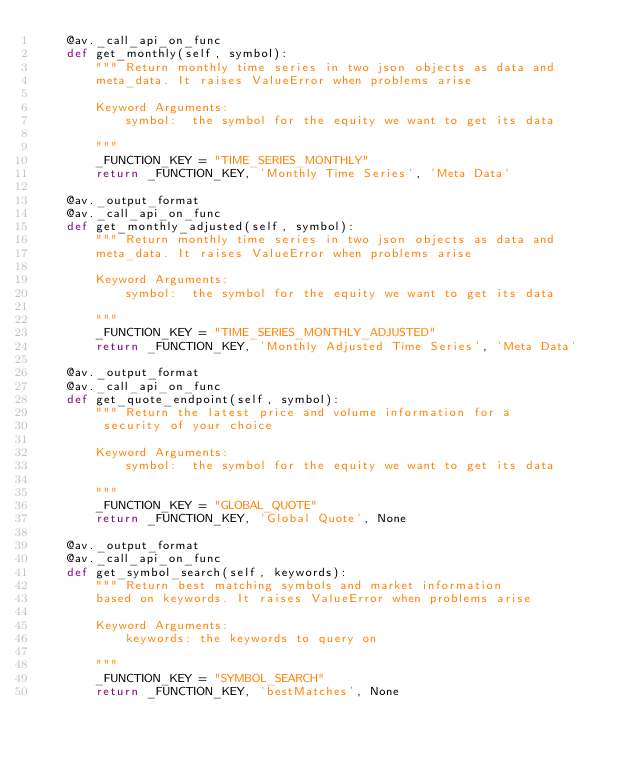Convert code to text. <code><loc_0><loc_0><loc_500><loc_500><_Python_>    @av._call_api_on_func
    def get_monthly(self, symbol):
        """ Return monthly time series in two json objects as data and
        meta_data. It raises ValueError when problems arise

        Keyword Arguments:
            symbol:  the symbol for the equity we want to get its data

        """
        _FUNCTION_KEY = "TIME_SERIES_MONTHLY"
        return _FUNCTION_KEY, 'Monthly Time Series', 'Meta Data'

    @av._output_format
    @av._call_api_on_func
    def get_monthly_adjusted(self, symbol):
        """ Return monthly time series in two json objects as data and
        meta_data. It raises ValueError when problems arise

        Keyword Arguments:
            symbol:  the symbol for the equity we want to get its data

        """
        _FUNCTION_KEY = "TIME_SERIES_MONTHLY_ADJUSTED"
        return _FUNCTION_KEY, 'Monthly Adjusted Time Series', 'Meta Data'

    @av._output_format
    @av._call_api_on_func
    def get_quote_endpoint(self, symbol):
        """ Return the latest price and volume information for a
         security of your choice

        Keyword Arguments:
            symbol:  the symbol for the equity we want to get its data

        """
        _FUNCTION_KEY = "GLOBAL_QUOTE"
        return _FUNCTION_KEY, 'Global Quote', None

    @av._output_format
    @av._call_api_on_func
    def get_symbol_search(self, keywords):
        """ Return best matching symbols and market information
        based on keywords. It raises ValueError when problems arise

        Keyword Arguments:
            keywords: the keywords to query on

        """
        _FUNCTION_KEY = "SYMBOL_SEARCH"
        return _FUNCTION_KEY, 'bestMatches', None
</code> 